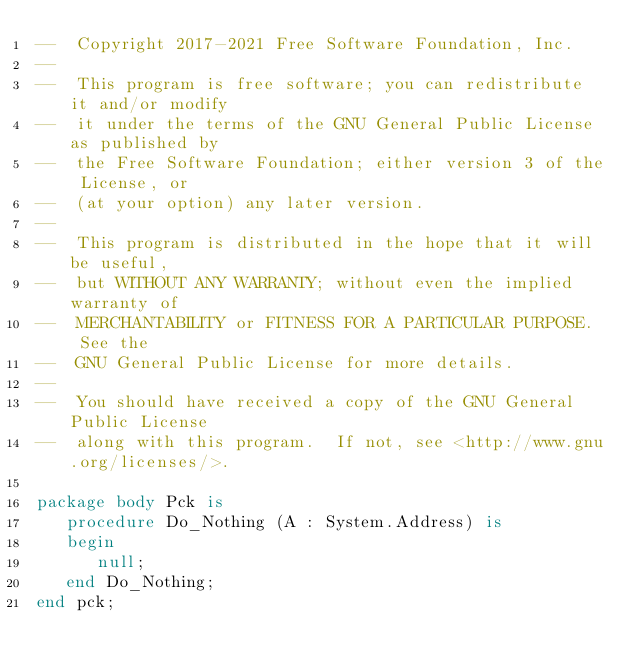<code> <loc_0><loc_0><loc_500><loc_500><_Ada_>--  Copyright 2017-2021 Free Software Foundation, Inc.
--
--  This program is free software; you can redistribute it and/or modify
--  it under the terms of the GNU General Public License as published by
--  the Free Software Foundation; either version 3 of the License, or
--  (at your option) any later version.
--
--  This program is distributed in the hope that it will be useful,
--  but WITHOUT ANY WARRANTY; without even the implied warranty of
--  MERCHANTABILITY or FITNESS FOR A PARTICULAR PURPOSE.  See the
--  GNU General Public License for more details.
--
--  You should have received a copy of the GNU General Public License
--  along with this program.  If not, see <http://www.gnu.org/licenses/>.

package body Pck is
   procedure Do_Nothing (A : System.Address) is
   begin
      null;
   end Do_Nothing;
end pck;

</code> 